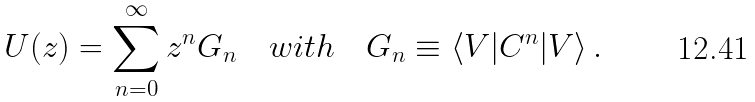<formula> <loc_0><loc_0><loc_500><loc_500>U ( z ) = \sum _ { n = 0 } ^ { \infty } z ^ { n } G _ { n } \quad w i t h \quad G _ { n } \equiv \langle V | C ^ { n } | V \rangle \, .</formula> 